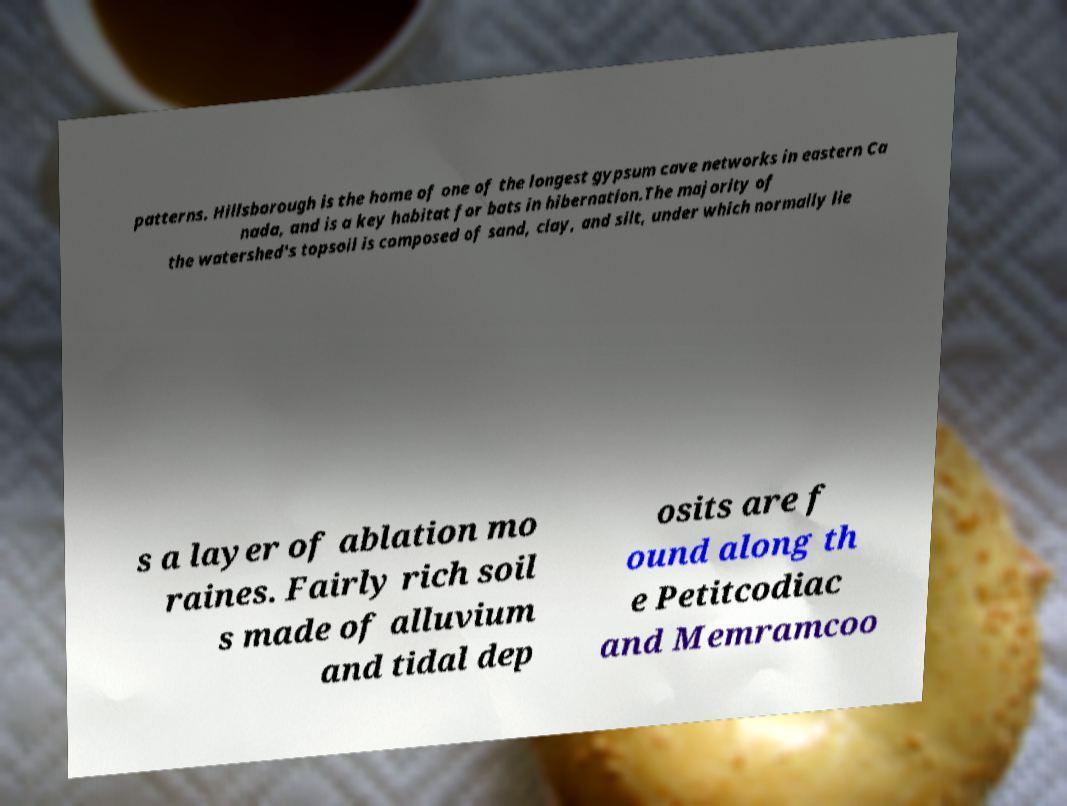Please read and relay the text visible in this image. What does it say? patterns. Hillsborough is the home of one of the longest gypsum cave networks in eastern Ca nada, and is a key habitat for bats in hibernation.The majority of the watershed's topsoil is composed of sand, clay, and silt, under which normally lie s a layer of ablation mo raines. Fairly rich soil s made of alluvium and tidal dep osits are f ound along th e Petitcodiac and Memramcoo 